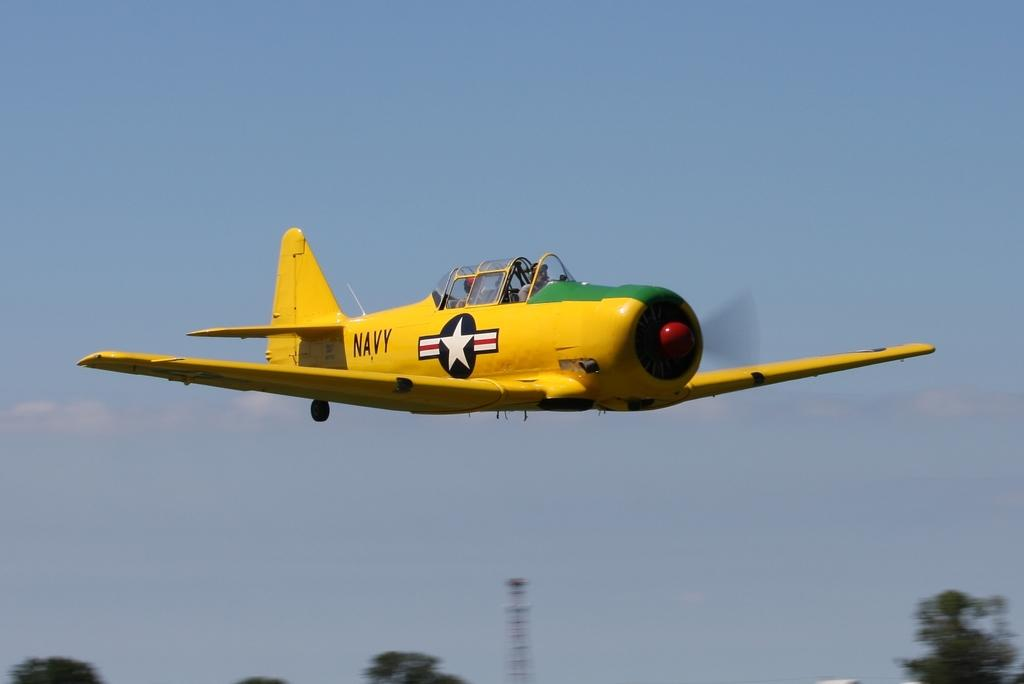<image>
Render a clear and concise summary of the photo. Yellow Navy airplane with a flag logo on the left side. 